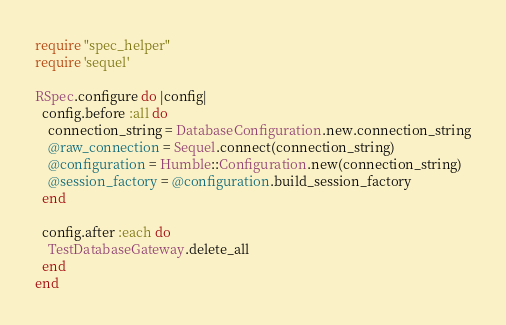Convert code to text. <code><loc_0><loc_0><loc_500><loc_500><_Ruby_>require "spec_helper"
require 'sequel'

RSpec.configure do |config|
  config.before :all do
    connection_string = DatabaseConfiguration.new.connection_string
    @raw_connection = Sequel.connect(connection_string)
    @configuration = Humble::Configuration.new(connection_string)
    @session_factory = @configuration.build_session_factory
  end

  config.after :each do
    TestDatabaseGateway.delete_all
  end
end
</code> 